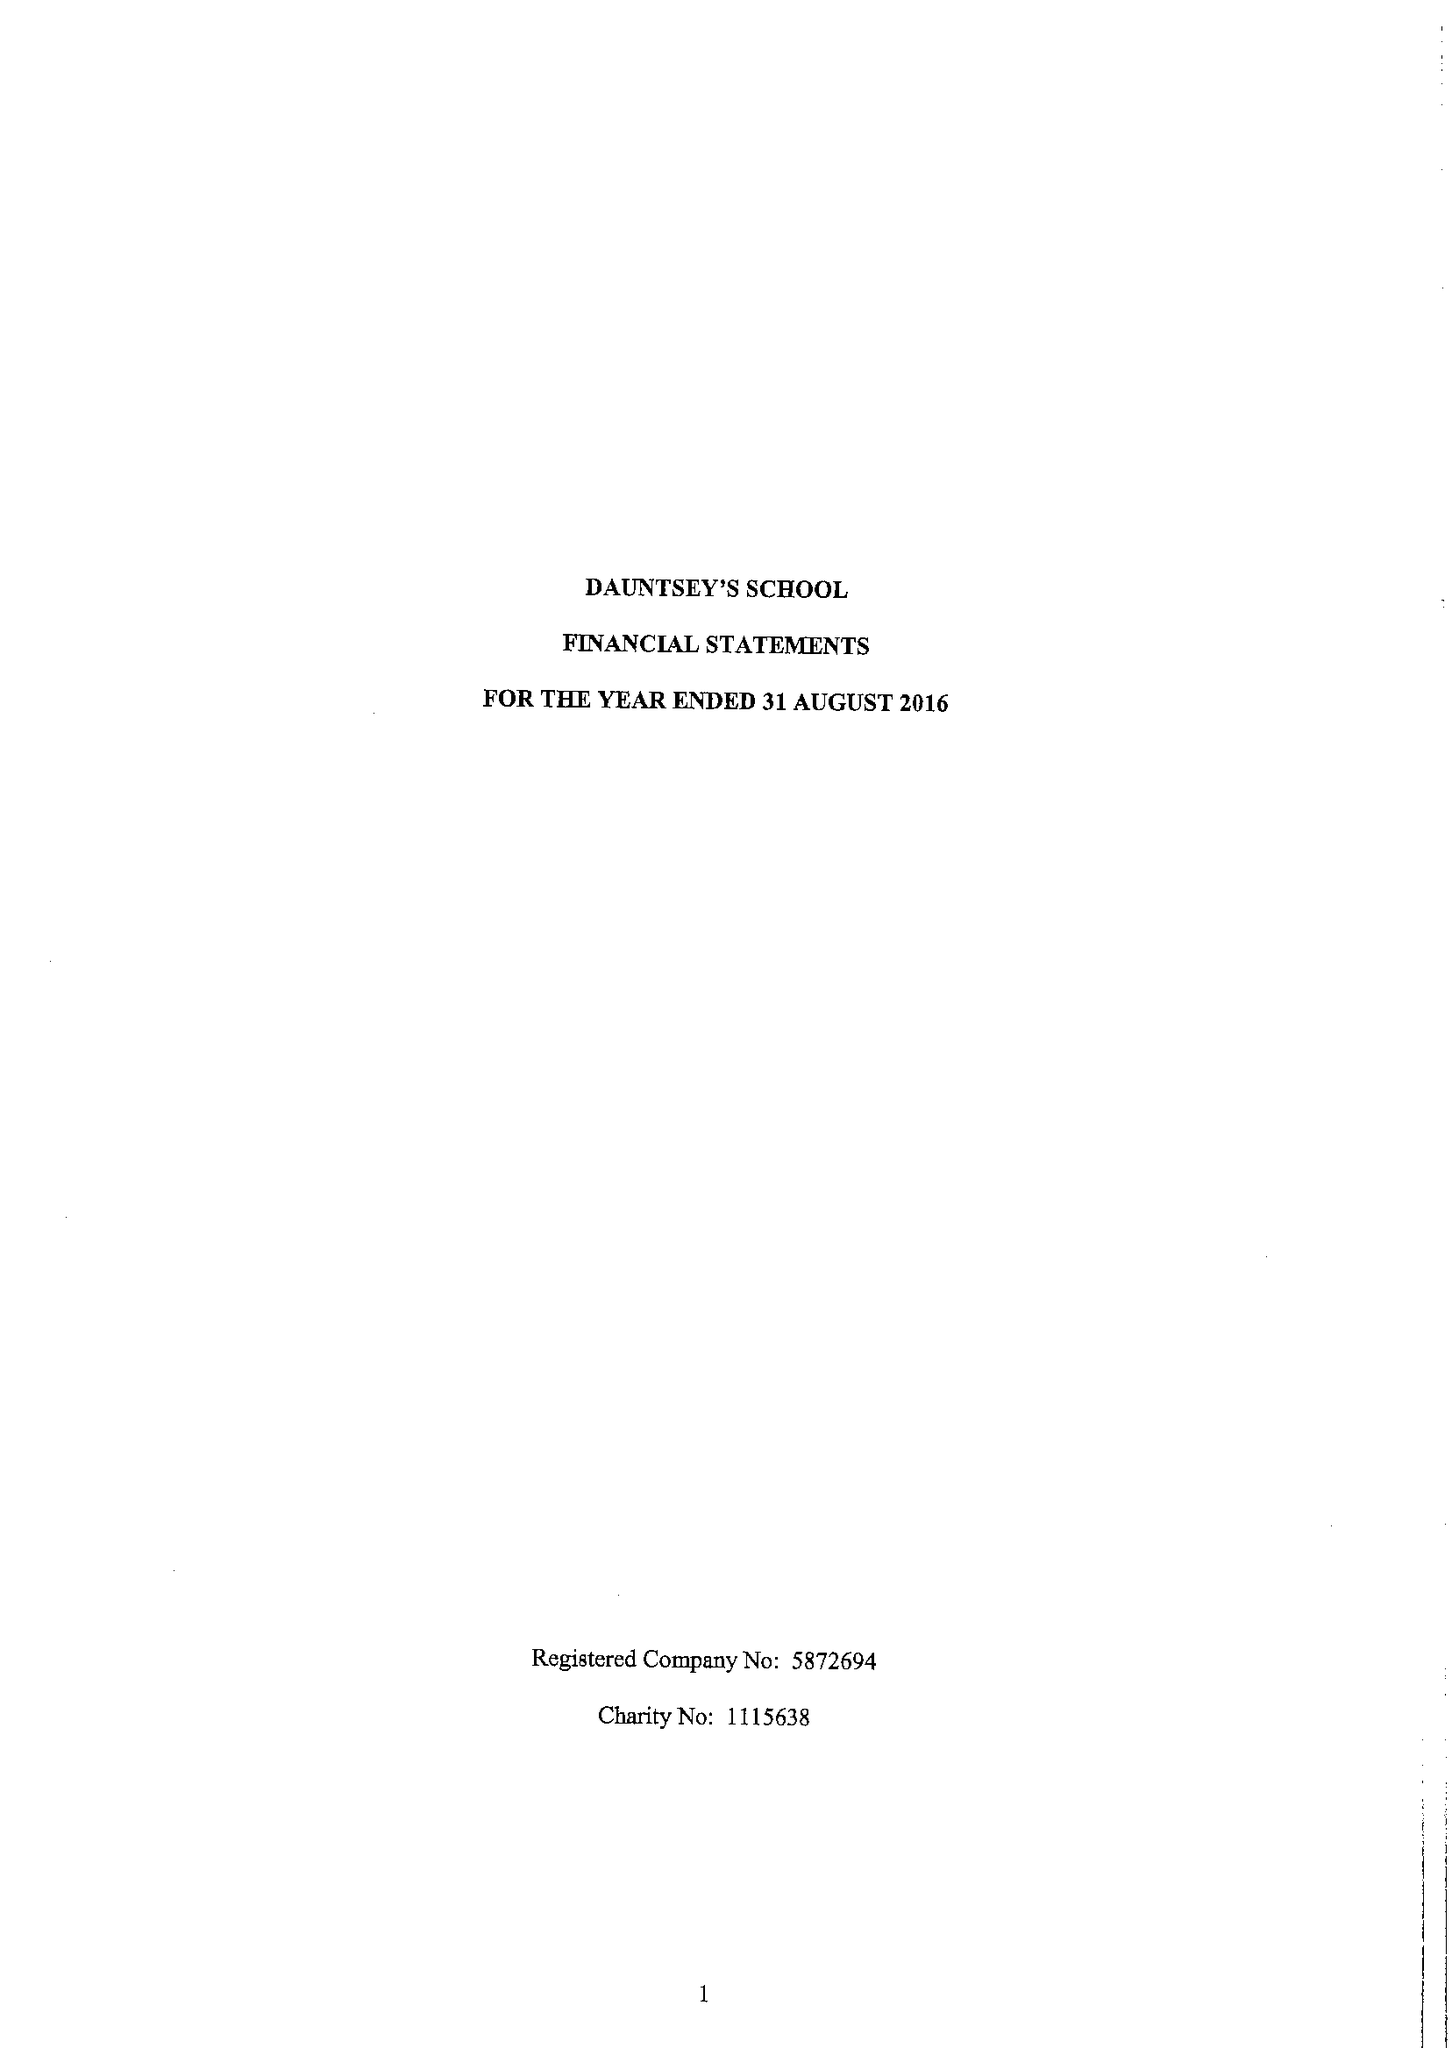What is the value for the address__postcode?
Answer the question using a single word or phrase. SN10 4HE 